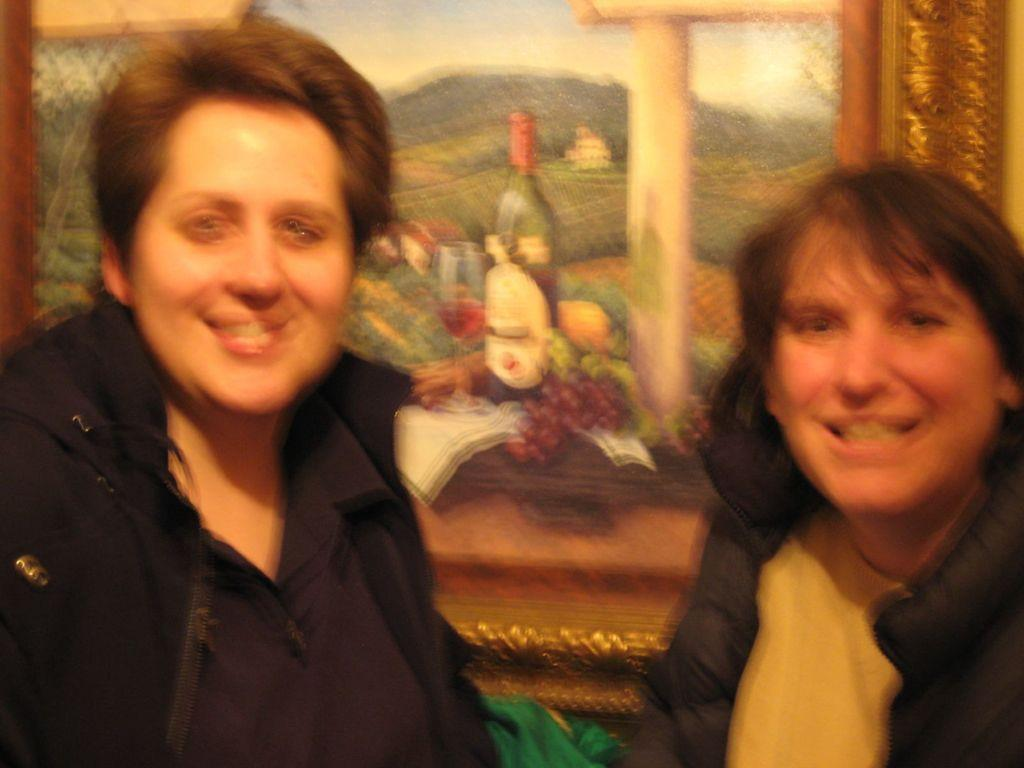What is the nature of the image in the picture? There is a blurry image in the picture. How many people are present in the image? There are 2 people in the image. What are the people in the image doing? The people are looking and smiling at someone. What type of needle can be seen being used by someone in the image? There is no needle present in the image. What is the price of the attempt made by the person being looked at and smiled at in the image? There is no indication of any price or attempt in the image. 